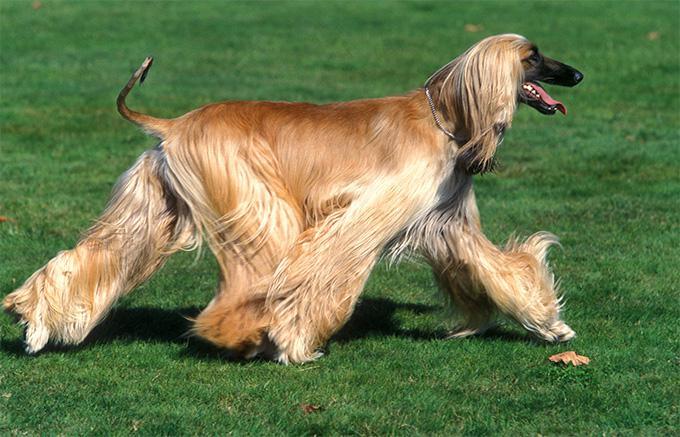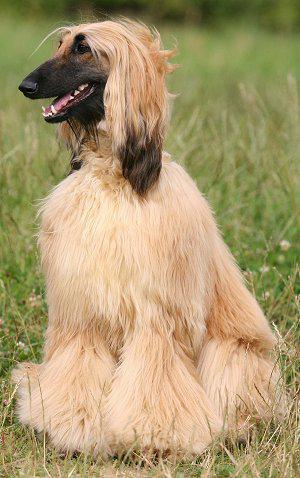The first image is the image on the left, the second image is the image on the right. For the images shown, is this caption "An image contains one standing hound with its body and head in profile." true? Answer yes or no. Yes. 